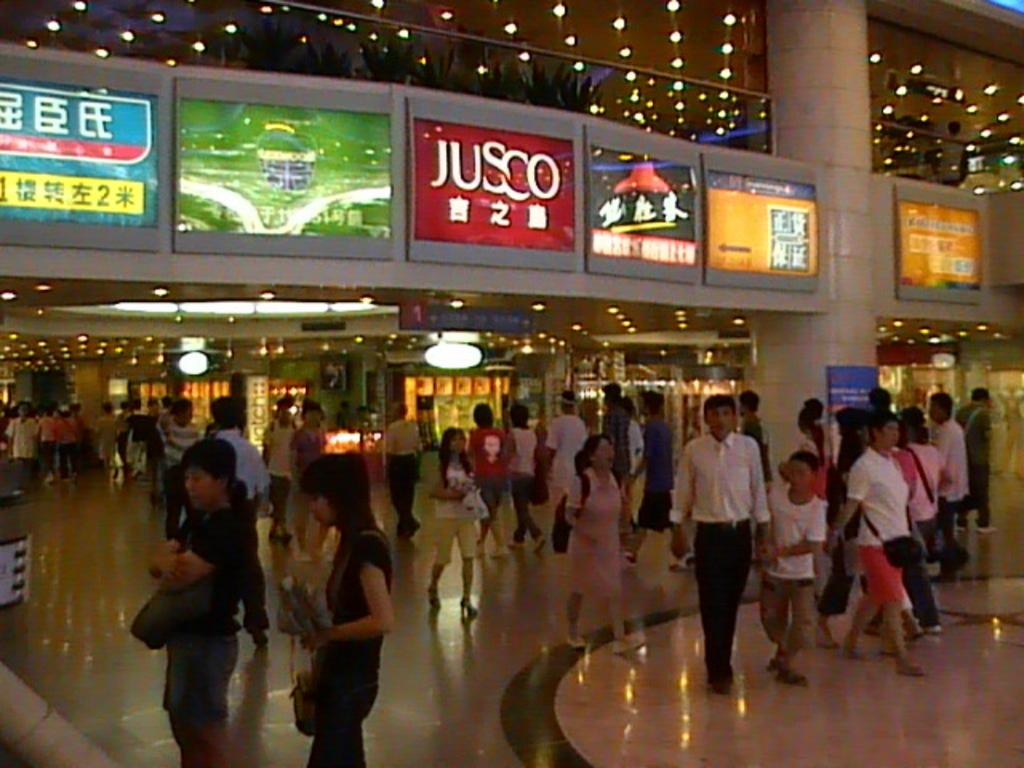What are the people in the image doing? The people in the image are walking. What can be seen on the sides of the street in the image? There are hoardings in the image. What can be seen in the background of the image? There are lights visible in the background of the image. What is at the bottom of the image? There is a floor at the bottom of the image. What type of hat is the station wearing in the image? There is no station or hat present in the image. What is the gate used for in the image? There is no gate present in the image. 